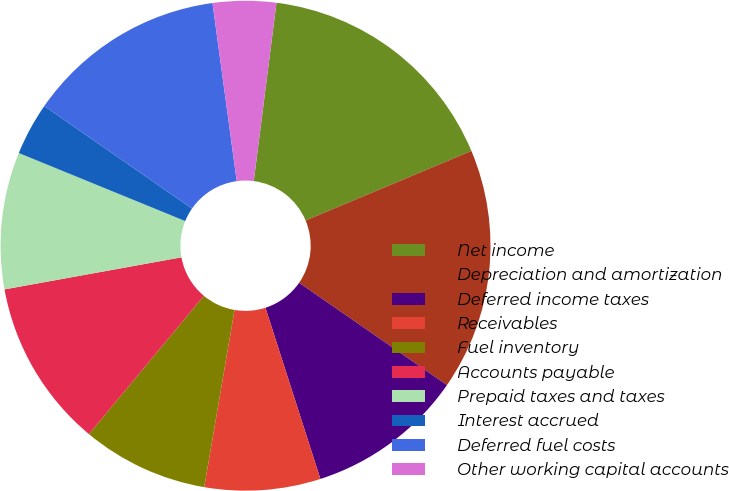<chart> <loc_0><loc_0><loc_500><loc_500><pie_chart><fcel>Net income<fcel>Depreciation and amortization<fcel>Deferred income taxes<fcel>Receivables<fcel>Fuel inventory<fcel>Accounts payable<fcel>Prepaid taxes and taxes<fcel>Interest accrued<fcel>Deferred fuel costs<fcel>Other working capital accounts<nl><fcel>16.66%<fcel>15.96%<fcel>10.42%<fcel>7.64%<fcel>8.34%<fcel>11.11%<fcel>9.03%<fcel>3.48%<fcel>13.19%<fcel>4.17%<nl></chart> 